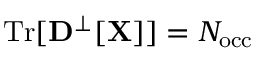<formula> <loc_0><loc_0><loc_500><loc_500>T r [ { D } ^ { \perp } [ { X } ] ] = N _ { o c c }</formula> 